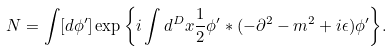<formula> <loc_0><loc_0><loc_500><loc_500>N = \int [ d \phi ^ { \prime } ] \exp { \left \{ i \int d ^ { D } x \frac { 1 } { 2 } \phi ^ { \prime } \ast ( - \partial ^ { 2 } - m ^ { 2 } + i \epsilon ) \phi ^ { \prime } \right \} } .</formula> 